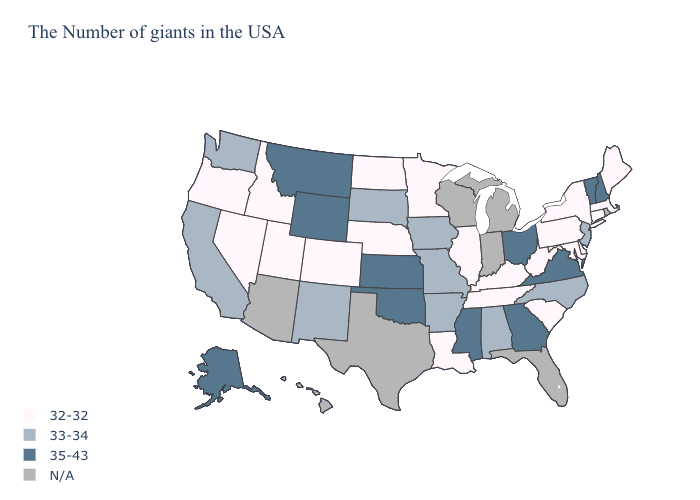What is the value of Indiana?
Answer briefly. N/A. Name the states that have a value in the range 33-34?
Keep it brief. New Jersey, North Carolina, Alabama, Missouri, Arkansas, Iowa, South Dakota, New Mexico, California, Washington. Name the states that have a value in the range 32-32?
Keep it brief. Maine, Massachusetts, Connecticut, New York, Delaware, Maryland, Pennsylvania, South Carolina, West Virginia, Kentucky, Tennessee, Illinois, Louisiana, Minnesota, Nebraska, North Dakota, Colorado, Utah, Idaho, Nevada, Oregon. What is the value of California?
Concise answer only. 33-34. What is the value of Delaware?
Short answer required. 32-32. What is the value of Texas?
Be succinct. N/A. Name the states that have a value in the range N/A?
Be succinct. Rhode Island, Florida, Michigan, Indiana, Wisconsin, Texas, Arizona, Hawaii. What is the value of Maine?
Write a very short answer. 32-32. Does Connecticut have the lowest value in the Northeast?
Be succinct. Yes. Among the states that border Oregon , which have the highest value?
Concise answer only. California, Washington. Which states have the lowest value in the USA?
Answer briefly. Maine, Massachusetts, Connecticut, New York, Delaware, Maryland, Pennsylvania, South Carolina, West Virginia, Kentucky, Tennessee, Illinois, Louisiana, Minnesota, Nebraska, North Dakota, Colorado, Utah, Idaho, Nevada, Oregon. How many symbols are there in the legend?
Write a very short answer. 4. What is the value of Iowa?
Concise answer only. 33-34. Name the states that have a value in the range 35-43?
Keep it brief. New Hampshire, Vermont, Virginia, Ohio, Georgia, Mississippi, Kansas, Oklahoma, Wyoming, Montana, Alaska. 